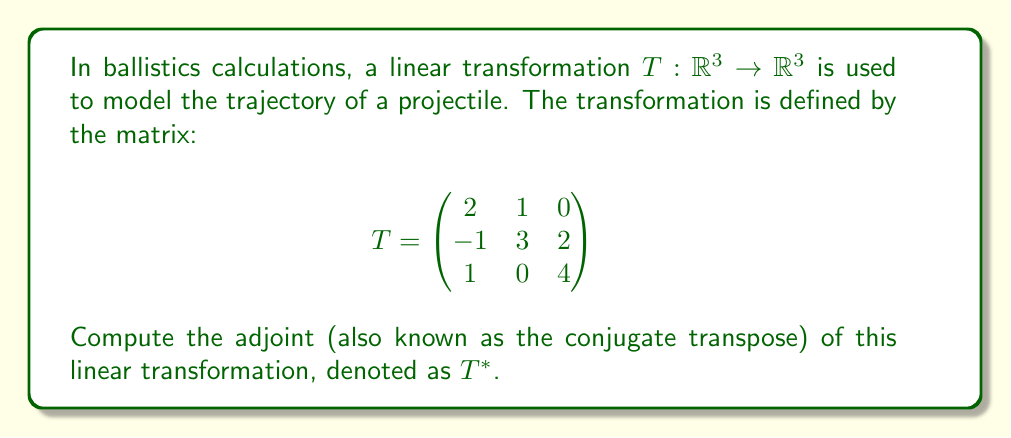Could you help me with this problem? To find the adjoint of a linear transformation represented by a matrix, we need to follow these steps:

1. Transpose the matrix:
   First, we interchange the rows and columns of the original matrix.

   $$T^T = \begin{pmatrix}
   2 & -1 & 1 \\
   1 & 3 & 0 \\
   0 & 2 & 4
   \end{pmatrix}$$

2. Take the complex conjugate of each entry:
   In this case, all entries are real numbers, so the complex conjugate is the same as the original number.

3. The resulting matrix is the adjoint:
   Since all entries are real, the adjoint $T^*$ is equal to the transpose $T^T$.

Therefore, the adjoint of the linear transformation $T$ is:

$$T^* = \begin{pmatrix}
2 & -1 & 1 \\
1 & 3 & 0 \\
0 & 2 & 4
\end{pmatrix}$$

This adjoint matrix $T^*$ represents the linear transformation that is the adjoint of the original transformation $T$.
Answer: $$T^* = \begin{pmatrix}
2 & -1 & 1 \\
1 & 3 & 0 \\
0 & 2 & 4
\end{pmatrix}$$ 